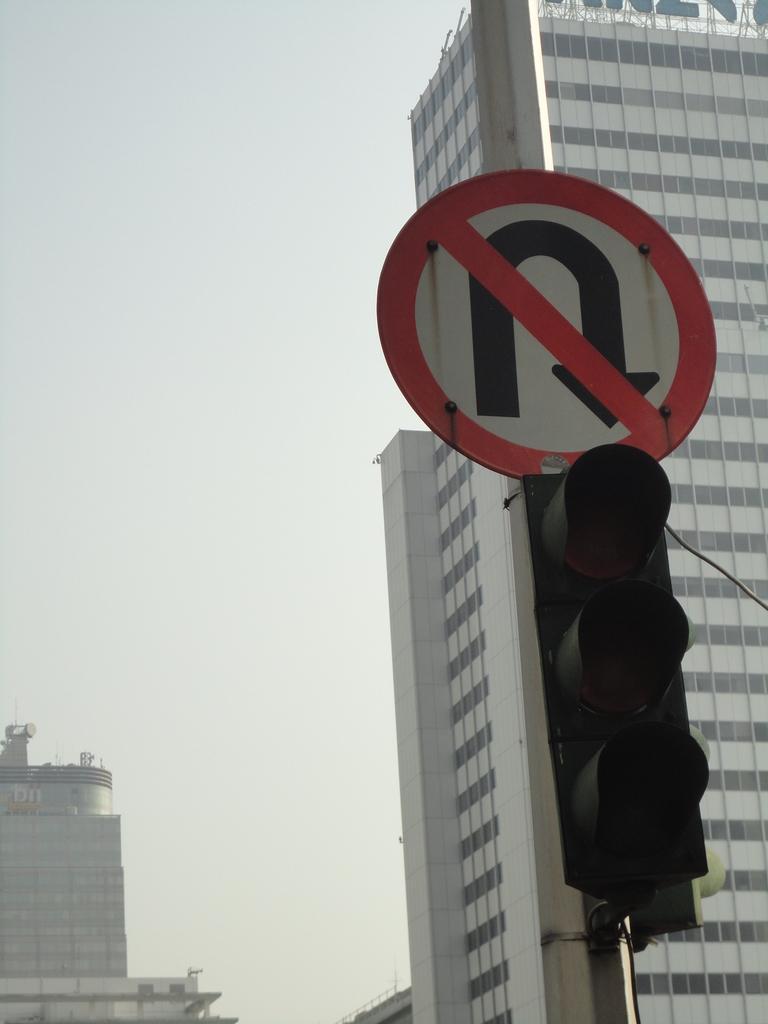Can you describe this image briefly? On the right side we can see a traffic signal and sign board are on a pole. In the background there are buildings, glass doors, name board, poles and sky. 